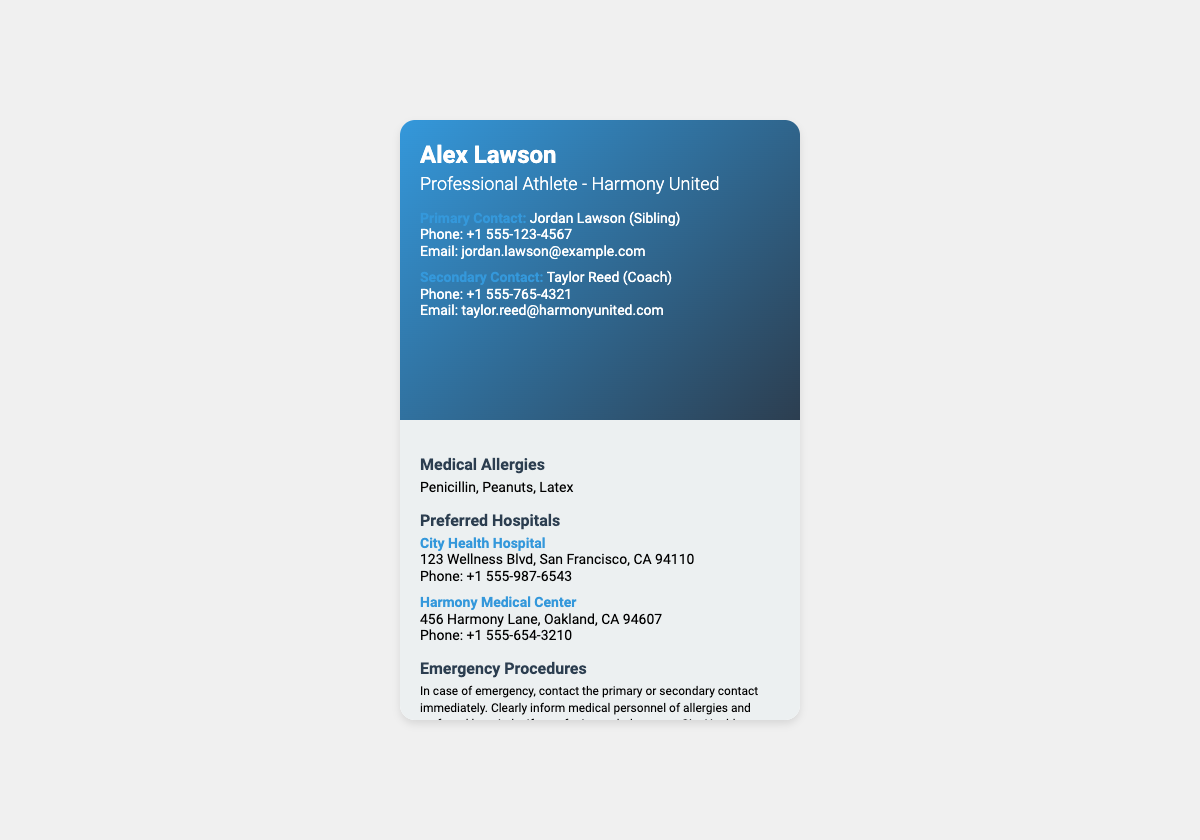What is the name of the primary contact? The primary contact's name is listed as Jordan Lawson in the document.
Answer: Jordan Lawson What are the medical allergies mentioned? The document lists the medical allergies as Penicillin, Peanuts, and Latex.
Answer: Penicillin, Peanuts, Latex What is the phone number of Harmony Medical Center? The document provides a specific phone number for Harmony Medical Center as +1 555-654-3210.
Answer: +1 555-654-3210 How many preferred hospitals are listed? There are two preferred hospitals mentioned in the document: City Health Hospital and Harmony Medical Center.
Answer: 2 What is the quote on the card? The document includes a quote that emphasizes teamwork and support.
Answer: "Harmony is the strength and support of the team." What is the email address of the secondary contact? The document specifies the email address associated with the secondary contact, Taylor Reed.
Answer: taylor.reed@harmonyunited.com What emergency procedure is suggested in case of an emergency? The document indicates to contact the primary or secondary contact immediately and inform medical personnel about allergies.
Answer: Contact primary or secondary contact immediately What city is City Health Hospital located in? The address provided in the document states that City Health Hospital is located in San Francisco.
Answer: San Francisco 